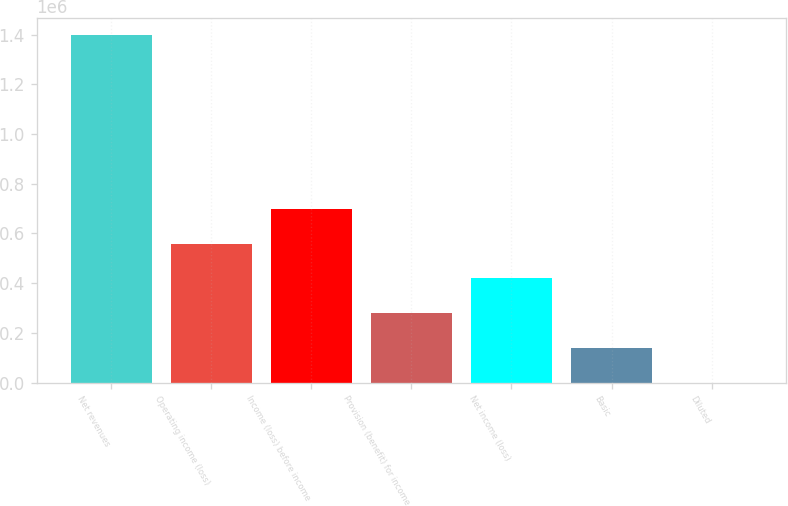<chart> <loc_0><loc_0><loc_500><loc_500><bar_chart><fcel>Net revenues<fcel>Operating income (loss)<fcel>Income (loss) before income<fcel>Provision (benefit) for income<fcel>Net income (loss)<fcel>Basic<fcel>Diluted<nl><fcel>1.39785e+06<fcel>559139<fcel>698923<fcel>279570<fcel>419354<fcel>139785<fcel>0.85<nl></chart> 